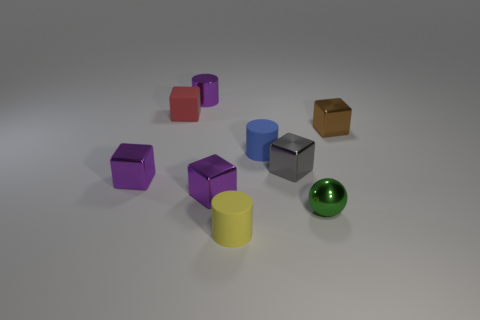Subtract all small matte cylinders. How many cylinders are left? 1 Subtract all yellow balls. How many purple blocks are left? 2 Add 1 big brown rubber cubes. How many objects exist? 10 Subtract 3 cylinders. How many cylinders are left? 0 Subtract all yellow cylinders. How many cylinders are left? 2 Subtract all cylinders. How many objects are left? 6 Add 8 blue metal cylinders. How many blue metal cylinders exist? 8 Subtract 1 brown cubes. How many objects are left? 8 Subtract all gray balls. Subtract all green blocks. How many balls are left? 1 Subtract all tiny metallic spheres. Subtract all small metal objects. How many objects are left? 2 